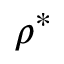<formula> <loc_0><loc_0><loc_500><loc_500>\rho ^ { * }</formula> 